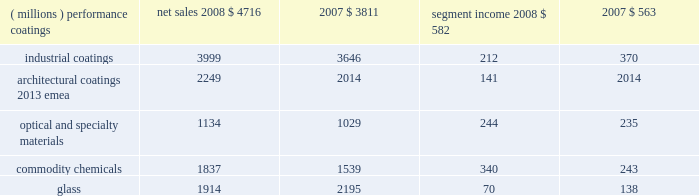Management 2019s discussion and analysis results of reportable business segments net sales segment income ( millions ) 2008 2007 2008 2007 .
Performance coatings sales increased $ 905 million or 24% ( 24 % ) in 2008 .
Sales increased 21% ( 21 % ) due to acquisitions , largely due to the impact of the sigmakalon protective and marine coatings business .
Sales also grew by 3% ( 3 % ) due to higher selling prices and 2% ( 2 % ) due to the positive impact of foreign currency translation .
Sales volumes declined 2% ( 2 % ) as reduced volumes in architectural coatings 2013 americas and asia pacific and automotive refinish were not fully offset by improved volumes in the aerospace and protective and marine businesses .
Volume growth in the aerospace businesses occurred throughout the world , while the volume growth in protective and marine coatings occurred primarily in asia .
Segment income increased $ 19 million in 2008 .
Factors increasing segment income were the positive impact of acquisitions , lower overhead costs and the positive impact of foreign currency translation .
The benefit of higher selling prices more than offset the negative impact of inflation , including higher raw materials and benefit costs .
Segment income was reduced by the impact of the lower sales volumes in architectural coatings and automotive refinish , which more than offset the benefit of volume gains in the aerospace and protective and marine coatings businesses .
Industrial coatings sales increased $ 353 million or 10% ( 10 % ) in 2008 .
Sales increased 11% ( 11 % ) due to acquisitions , including the impact of the sigmakalon industrial coatings business .
Sales also grew 3% ( 3 % ) due to the positive impact of foreign currency translation , and 1% ( 1 % ) from higher selling prices .
Sales volumes declined 5% ( 5 % ) as reduced volumes were experienced in all three businesses , reflecting the substantial declines in global demand .
Volume declines in the automotive and industrial businesses were primarily in the u.s .
And canada .
Additional volume declines in the european and asian regions were experienced by the industrial coatings business .
In packaging coatings , volume declines in europe were only partially offset by gains in asia and north america .
Segment income declined $ 158 million in 2008 due to the lower volumes and inflation , including higher raw material and freight costs , the impact of which was only partially mitigated by the increased selling prices .
Segment income also declined due to higher selling and distribution costs , including higher bad debt expense .
Factors increasing segment income were the earnings of acquired businesses , the positive impact of foreign currency translation and lower manufacturing costs .
Architectural coatings - emea sales for the year were $ 2249 million .
This business was acquired in the sigmakalon acquisition .
Segment income was $ 141 million , which included amortization expense of $ 63 million related to acquired intangible assets and depreciation expense of $ 58 million .
Optical and specialty materials sales increased $ 105 million or 10% ( 10 % ) in 2008 .
Sales increased 5% ( 5 % ) due to higher volumes in our optical products business resulting from the launch of transitions optical 2019s next generation lens product , 3% ( 3 % ) due to the positive impact of foreign currency translation and 2% ( 2 % ) due to increased selling prices .
Segment income increased $ 9 million in 2008 .
The increase in segment income was the result of increased sales volumes and the favorable impact of currency partially offset by increased selling and marketing costs in the optical products business related to the transitions optical product launch mentioned above .
Increased selling prices only partially offset higher raw material costs , primarily in our silicas business .
Commodity chemicals sales increased $ 298 million or 19% ( 19 % ) in 2008 .
Sales increased 18% ( 18 % ) due to higher selling prices and 1% ( 1 % ) due to improved sales volumes .
Segment income increased $ 97 million in 2008 .
Segment income increased in large part due to higher selling prices , which more than offset the negative impact of inflation , primarily higher raw material and energy costs .
Segment income also improved due to lower manufacturing costs , while lower margin mix and equity earnings reduced segment income .
Glass sales decreased $ 281 million or 13% ( 13 % ) in 2008 .
Sales decreased 11% ( 11 % ) due to the divestiture of the automotive glass and services business in september 2008 and 4% ( 4 % ) due to lower sales volumes .
Sales increased 2% ( 2 % ) due to higher selling prices .
Segment income decreased $ 68 million in 2008 .
Segment income decreased due to the divestiture of the automotive glass and services business , lower volumes , the negative impact of inflation and lower equity earnings from our asian fiber glass joint ventures .
Factors increasing segment income were lower manufacturing costs , higher selling prices and stronger foreign currency .
Outlook overall global economic activity was volatile in 2008 with an overall downward trend .
The north american economy continued a slowing trend which began during the second half of 2006 and continued all of 2007 .
The impact of the weakening u.s .
Economy was particularly 2008 ppg annual report and form 10-k 17 .
What was the net income margin in 2008 for the performance coatings segment? 
Computations: (582 / 4716)
Answer: 0.12341. 